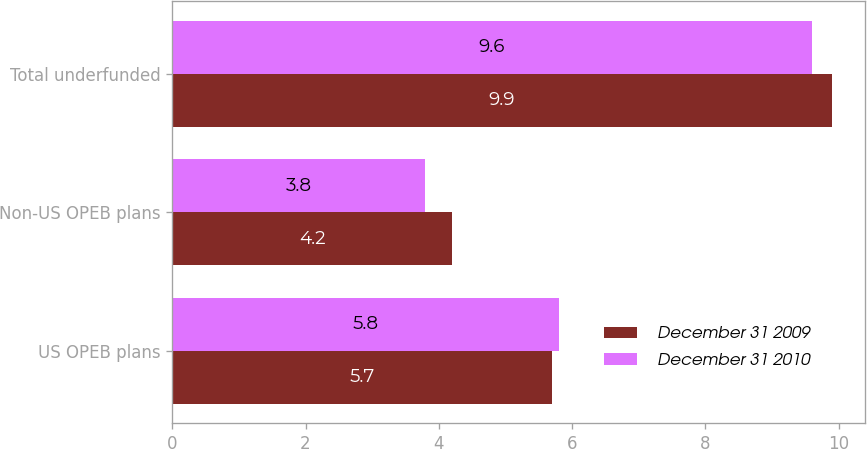Convert chart. <chart><loc_0><loc_0><loc_500><loc_500><stacked_bar_chart><ecel><fcel>US OPEB plans<fcel>Non-US OPEB plans<fcel>Total underfunded<nl><fcel>December 31 2009<fcel>5.7<fcel>4.2<fcel>9.9<nl><fcel>December 31 2010<fcel>5.8<fcel>3.8<fcel>9.6<nl></chart> 